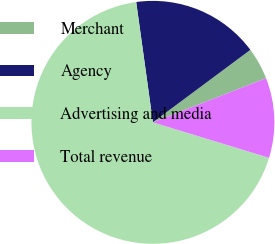Convert chart to OTSL. <chart><loc_0><loc_0><loc_500><loc_500><pie_chart><fcel>Merchant<fcel>Agency<fcel>Advertising and media<fcel>Total revenue<nl><fcel>4.26%<fcel>17.02%<fcel>68.09%<fcel>10.64%<nl></chart> 